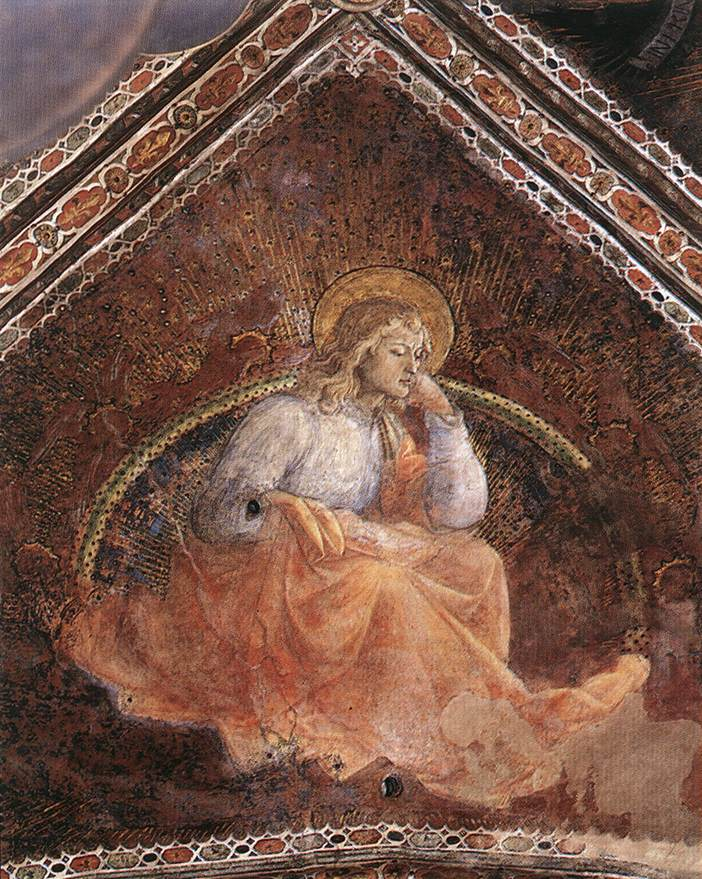What might the angel be thinking about? The angel depicted in the painting appears to be deep in contemplation, possibly reflecting on the sorrows and joys of humanity. It could be considering how to bring peace to those in distress or how to offer guidance to those who seek wisdom. The gentle expression and the serene yet slightly somber background hint at thoughts filled with empathy and a desire to heal. This scene captures a moment of divine introspection, where the angel is perhaps pondering how to fulfill its sacred duties and bring light and love to the world below. Do you think the angel has a message for us? Indeed, the angel may carry a timeless message of hope and compassion. Its contemplative pose suggests a reminder to all who view it: to take a moment to reflect on our lives, to seek purity and kindness in our actions, and to find strength in times of darkness. The angel's golden halo and serene expression convey a sense of divine reassurance, encouraging us to look within and around for the light amidst the shadows. This deeply reflective and serene image invites us to pause, contemplate, and aspire to a higher state of being, guided by love and compassion. 